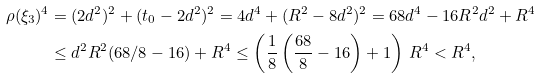Convert formula to latex. <formula><loc_0><loc_0><loc_500><loc_500>\rho ( \xi _ { 3 } ) ^ { 4 } & = ( 2 d ^ { 2 } ) ^ { 2 } + ( t _ { 0 } - 2 d ^ { 2 } ) ^ { 2 } = 4 d ^ { 4 } + ( R ^ { 2 } - 8 d ^ { 2 } ) ^ { 2 } = 6 8 d ^ { 4 } - 1 6 R ^ { 2 } d ^ { 2 } + R ^ { 4 } \\ & \leq d ^ { 2 } R ^ { 2 } ( 6 8 / 8 - 1 6 ) + R ^ { 4 } \leq \left ( \frac { 1 } { 8 } \left ( \frac { 6 8 } { 8 } - 1 6 \right ) + 1 \right ) \, R ^ { 4 } < R ^ { 4 } ,</formula> 